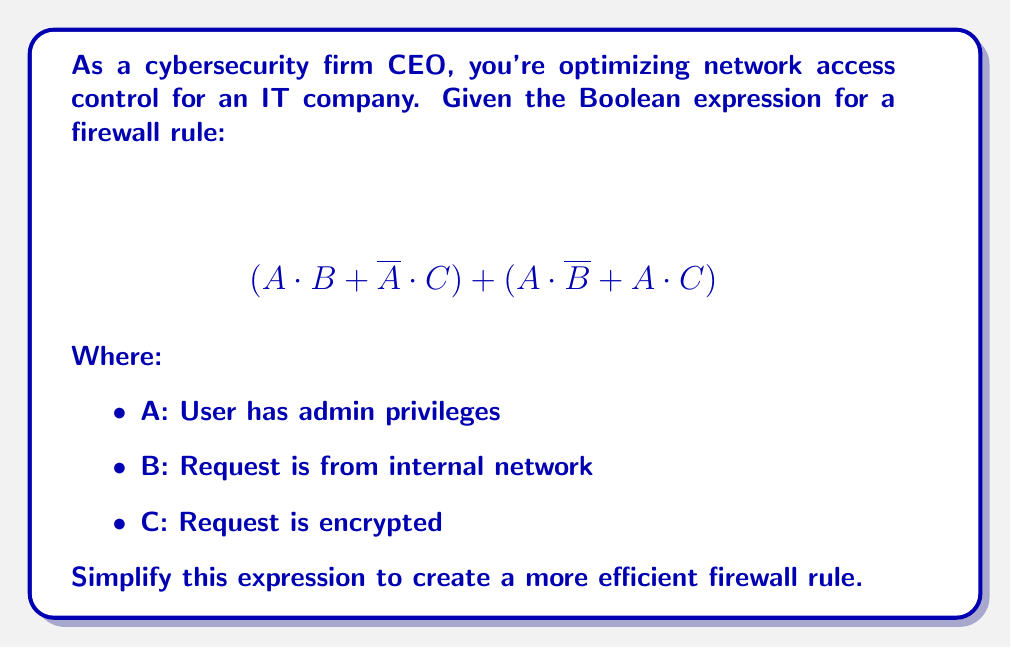Help me with this question. Let's simplify the expression step by step:

1) First, let's distribute A in the second part of the expression:
   $$(A \cdot B + \overline{A} \cdot C) + (A \cdot \overline{B} + A \cdot C)$$
   $$= (A \cdot B + \overline{A} \cdot C) + A \cdot (\overline{B} + C)$$

2) Now, we can apply the distributive property to the whole expression:
   $$= A \cdot B + \overline{A} \cdot C + A \cdot \overline{B} + A \cdot C$$

3) We can rearrange the terms:
   $$= A \cdot B + A \cdot \overline{B} + A \cdot C + \overline{A} \cdot C$$

4) Recognize that $A \cdot B + A \cdot \overline{B} = A \cdot (B + \overline{B}) = A$, as $B + \overline{B} = 1$:
   $$= A + A \cdot C + \overline{A} \cdot C$$

5) Factor out C from the last two terms:
   $$= A + C \cdot (A + \overline{A})$$

6) Since $A + \overline{A} = 1$, we can simplify further:
   $$= A + C$$

This simplified expression means the firewall will allow access if the user has admin privileges (A) OR if the request is encrypted (C).
Answer: $$A + C$$ 